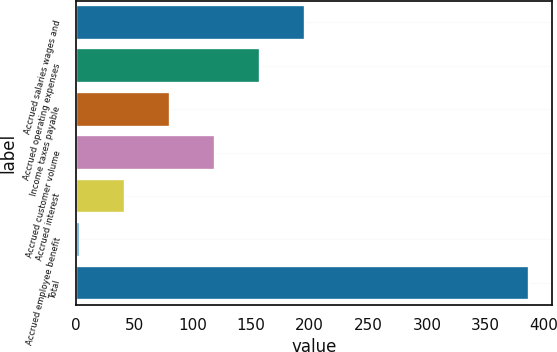Convert chart. <chart><loc_0><loc_0><loc_500><loc_500><bar_chart><fcel>Accrued salaries wages and<fcel>Accrued operating expenses<fcel>Income taxes payable<fcel>Accrued customer volume<fcel>Accrued interest<fcel>Accrued employee benefit<fcel>Total<nl><fcel>195.8<fcel>157.48<fcel>80.84<fcel>119.16<fcel>42.52<fcel>4.2<fcel>387.4<nl></chart> 